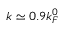<formula> <loc_0><loc_0><loc_500><loc_500>k \simeq 0 . 9 k _ { F } ^ { 0 }</formula> 